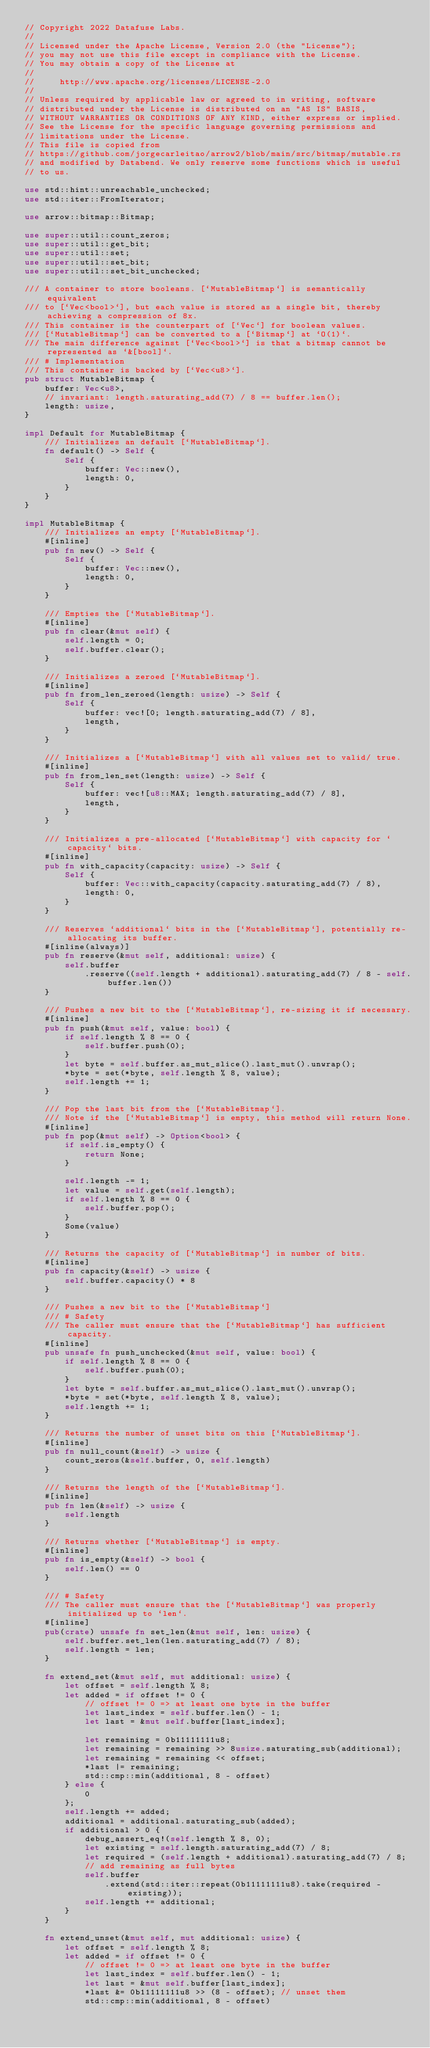<code> <loc_0><loc_0><loc_500><loc_500><_Rust_>// Copyright 2022 Datafuse Labs.
//
// Licensed under the Apache License, Version 2.0 (the "License");
// you may not use this file except in compliance with the License.
// You may obtain a copy of the License at
//
//     http://www.apache.org/licenses/LICENSE-2.0
//
// Unless required by applicable law or agreed to in writing, software
// distributed under the License is distributed on an "AS IS" BASIS,
// WITHOUT WARRANTIES OR CONDITIONS OF ANY KIND, either express or implied.
// See the License for the specific language governing permissions and
// limitations under the License.
// This file is copied from
// https://github.com/jorgecarleitao/arrow2/blob/main/src/bitmap/mutable.rs
// and modified by Databend. We only reserve some functions which is useful
// to us.

use std::hint::unreachable_unchecked;
use std::iter::FromIterator;

use arrow::bitmap::Bitmap;

use super::util::count_zeros;
use super::util::get_bit;
use super::util::set;
use super::util::set_bit;
use super::util::set_bit_unchecked;

/// A container to store booleans. [`MutableBitmap`] is semantically equivalent
/// to [`Vec<bool>`], but each value is stored as a single bit, thereby achieving a compression of 8x.
/// This container is the counterpart of [`Vec`] for boolean values.
/// [`MutableBitmap`] can be converted to a [`Bitmap`] at `O(1)`.
/// The main difference against [`Vec<bool>`] is that a bitmap cannot be represented as `&[bool]`.
/// # Implementation
/// This container is backed by [`Vec<u8>`].
pub struct MutableBitmap {
    buffer: Vec<u8>,
    // invariant: length.saturating_add(7) / 8 == buffer.len();
    length: usize,
}

impl Default for MutableBitmap {
    /// Initializes an default [`MutableBitmap`].
    fn default() -> Self {
        Self {
            buffer: Vec::new(),
            length: 0,
        }
    }
}

impl MutableBitmap {
    /// Initializes an empty [`MutableBitmap`].
    #[inline]
    pub fn new() -> Self {
        Self {
            buffer: Vec::new(),
            length: 0,
        }
    }

    /// Empties the [`MutableBitmap`].
    #[inline]
    pub fn clear(&mut self) {
        self.length = 0;
        self.buffer.clear();
    }

    /// Initializes a zeroed [`MutableBitmap`].
    #[inline]
    pub fn from_len_zeroed(length: usize) -> Self {
        Self {
            buffer: vec![0; length.saturating_add(7) / 8],
            length,
        }
    }

    /// Initializes a [`MutableBitmap`] with all values set to valid/ true.
    #[inline]
    pub fn from_len_set(length: usize) -> Self {
        Self {
            buffer: vec![u8::MAX; length.saturating_add(7) / 8],
            length,
        }
    }

    /// Initializes a pre-allocated [`MutableBitmap`] with capacity for `capacity` bits.
    #[inline]
    pub fn with_capacity(capacity: usize) -> Self {
        Self {
            buffer: Vec::with_capacity(capacity.saturating_add(7) / 8),
            length: 0,
        }
    }

    /// Reserves `additional` bits in the [`MutableBitmap`], potentially re-allocating its buffer.
    #[inline(always)]
    pub fn reserve(&mut self, additional: usize) {
        self.buffer
            .reserve((self.length + additional).saturating_add(7) / 8 - self.buffer.len())
    }

    /// Pushes a new bit to the [`MutableBitmap`], re-sizing it if necessary.
    #[inline]
    pub fn push(&mut self, value: bool) {
        if self.length % 8 == 0 {
            self.buffer.push(0);
        }
        let byte = self.buffer.as_mut_slice().last_mut().unwrap();
        *byte = set(*byte, self.length % 8, value);
        self.length += 1;
    }

    /// Pop the last bit from the [`MutableBitmap`].
    /// Note if the [`MutableBitmap`] is empty, this method will return None.
    #[inline]
    pub fn pop(&mut self) -> Option<bool> {
        if self.is_empty() {
            return None;
        }

        self.length -= 1;
        let value = self.get(self.length);
        if self.length % 8 == 0 {
            self.buffer.pop();
        }
        Some(value)
    }

    /// Returns the capacity of [`MutableBitmap`] in number of bits.
    #[inline]
    pub fn capacity(&self) -> usize {
        self.buffer.capacity() * 8
    }

    /// Pushes a new bit to the [`MutableBitmap`]
    /// # Safety
    /// The caller must ensure that the [`MutableBitmap`] has sufficient capacity.
    #[inline]
    pub unsafe fn push_unchecked(&mut self, value: bool) {
        if self.length % 8 == 0 {
            self.buffer.push(0);
        }
        let byte = self.buffer.as_mut_slice().last_mut().unwrap();
        *byte = set(*byte, self.length % 8, value);
        self.length += 1;
    }

    /// Returns the number of unset bits on this [`MutableBitmap`].
    #[inline]
    pub fn null_count(&self) -> usize {
        count_zeros(&self.buffer, 0, self.length)
    }

    /// Returns the length of the [`MutableBitmap`].
    #[inline]
    pub fn len(&self) -> usize {
        self.length
    }

    /// Returns whether [`MutableBitmap`] is empty.
    #[inline]
    pub fn is_empty(&self) -> bool {
        self.len() == 0
    }

    /// # Safety
    /// The caller must ensure that the [`MutableBitmap`] was properly initialized up to `len`.
    #[inline]
    pub(crate) unsafe fn set_len(&mut self, len: usize) {
        self.buffer.set_len(len.saturating_add(7) / 8);
        self.length = len;
    }

    fn extend_set(&mut self, mut additional: usize) {
        let offset = self.length % 8;
        let added = if offset != 0 {
            // offset != 0 => at least one byte in the buffer
            let last_index = self.buffer.len() - 1;
            let last = &mut self.buffer[last_index];

            let remaining = 0b11111111u8;
            let remaining = remaining >> 8usize.saturating_sub(additional);
            let remaining = remaining << offset;
            *last |= remaining;
            std::cmp::min(additional, 8 - offset)
        } else {
            0
        };
        self.length += added;
        additional = additional.saturating_sub(added);
        if additional > 0 {
            debug_assert_eq!(self.length % 8, 0);
            let existing = self.length.saturating_add(7) / 8;
            let required = (self.length + additional).saturating_add(7) / 8;
            // add remaining as full bytes
            self.buffer
                .extend(std::iter::repeat(0b11111111u8).take(required - existing));
            self.length += additional;
        }
    }

    fn extend_unset(&mut self, mut additional: usize) {
        let offset = self.length % 8;
        let added = if offset != 0 {
            // offset != 0 => at least one byte in the buffer
            let last_index = self.buffer.len() - 1;
            let last = &mut self.buffer[last_index];
            *last &= 0b11111111u8 >> (8 - offset); // unset them
            std::cmp::min(additional, 8 - offset)</code> 